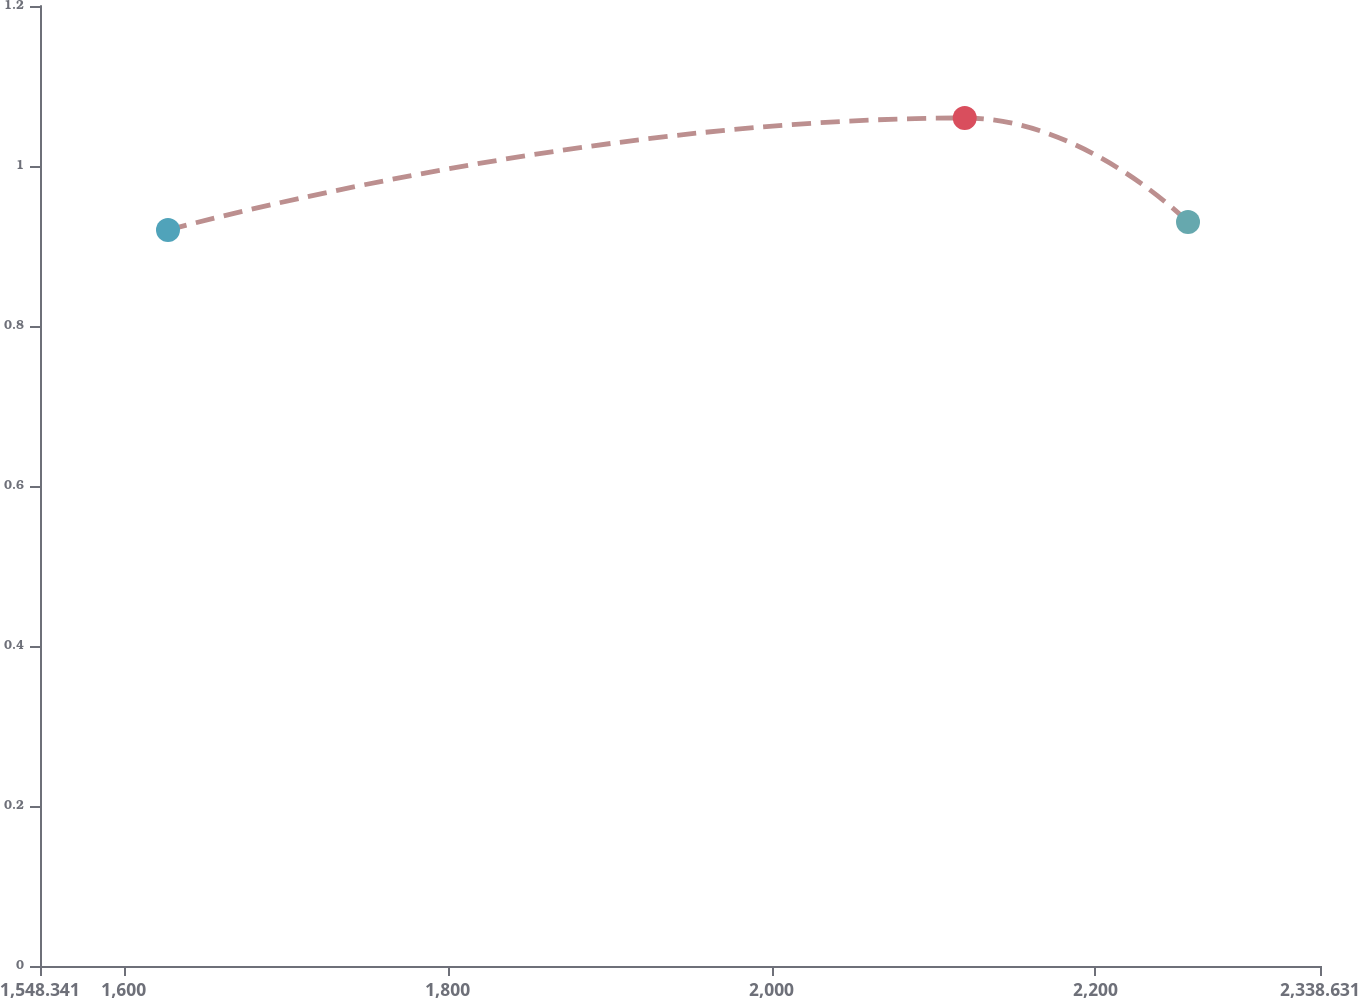Convert chart to OTSL. <chart><loc_0><loc_0><loc_500><loc_500><line_chart><ecel><fcel>Unnamed: 1<nl><fcel>1627.37<fcel>0.92<nl><fcel>2119.28<fcel>1.06<nl><fcel>2257.14<fcel>0.93<nl><fcel>2340.92<fcel>1.03<nl><fcel>2417.66<fcel>0.94<nl></chart> 